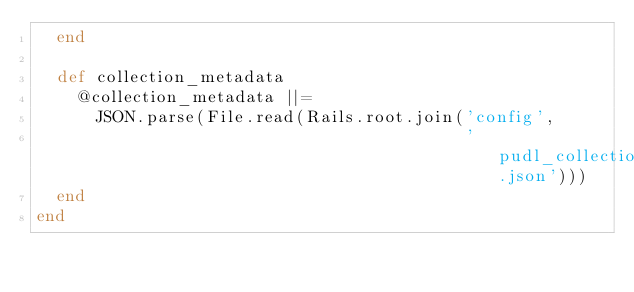Convert code to text. <code><loc_0><loc_0><loc_500><loc_500><_Ruby_>  end

  def collection_metadata
    @collection_metadata ||=
      JSON.parse(File.read(Rails.root.join('config',
                                           'pudl_collections.json')))
  end
end
</code> 